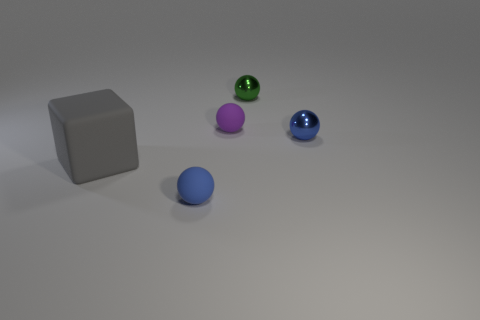What color is the other small matte object that is the same shape as the purple object?
Your answer should be compact. Blue. What size is the purple rubber object that is the same shape as the tiny green thing?
Make the answer very short. Small. Is the number of blue rubber things right of the small green sphere greater than the number of large rubber blocks right of the purple matte thing?
Provide a short and direct response. No. The tiny rubber thing in front of the gray block is what color?
Offer a very short reply. Blue. Is the shape of the tiny metallic thing that is right of the green metal sphere the same as the gray object on the left side of the green object?
Offer a very short reply. No. Are there any blue things of the same size as the green metal ball?
Offer a very short reply. Yes. There is a small blue ball behind the gray rubber block; what is its material?
Make the answer very short. Metal. Are the object left of the blue rubber object and the purple thing made of the same material?
Give a very brief answer. Yes. Is there a small green rubber cylinder?
Make the answer very short. No. There is a small sphere that is the same material as the small purple object; what color is it?
Offer a terse response. Blue. 